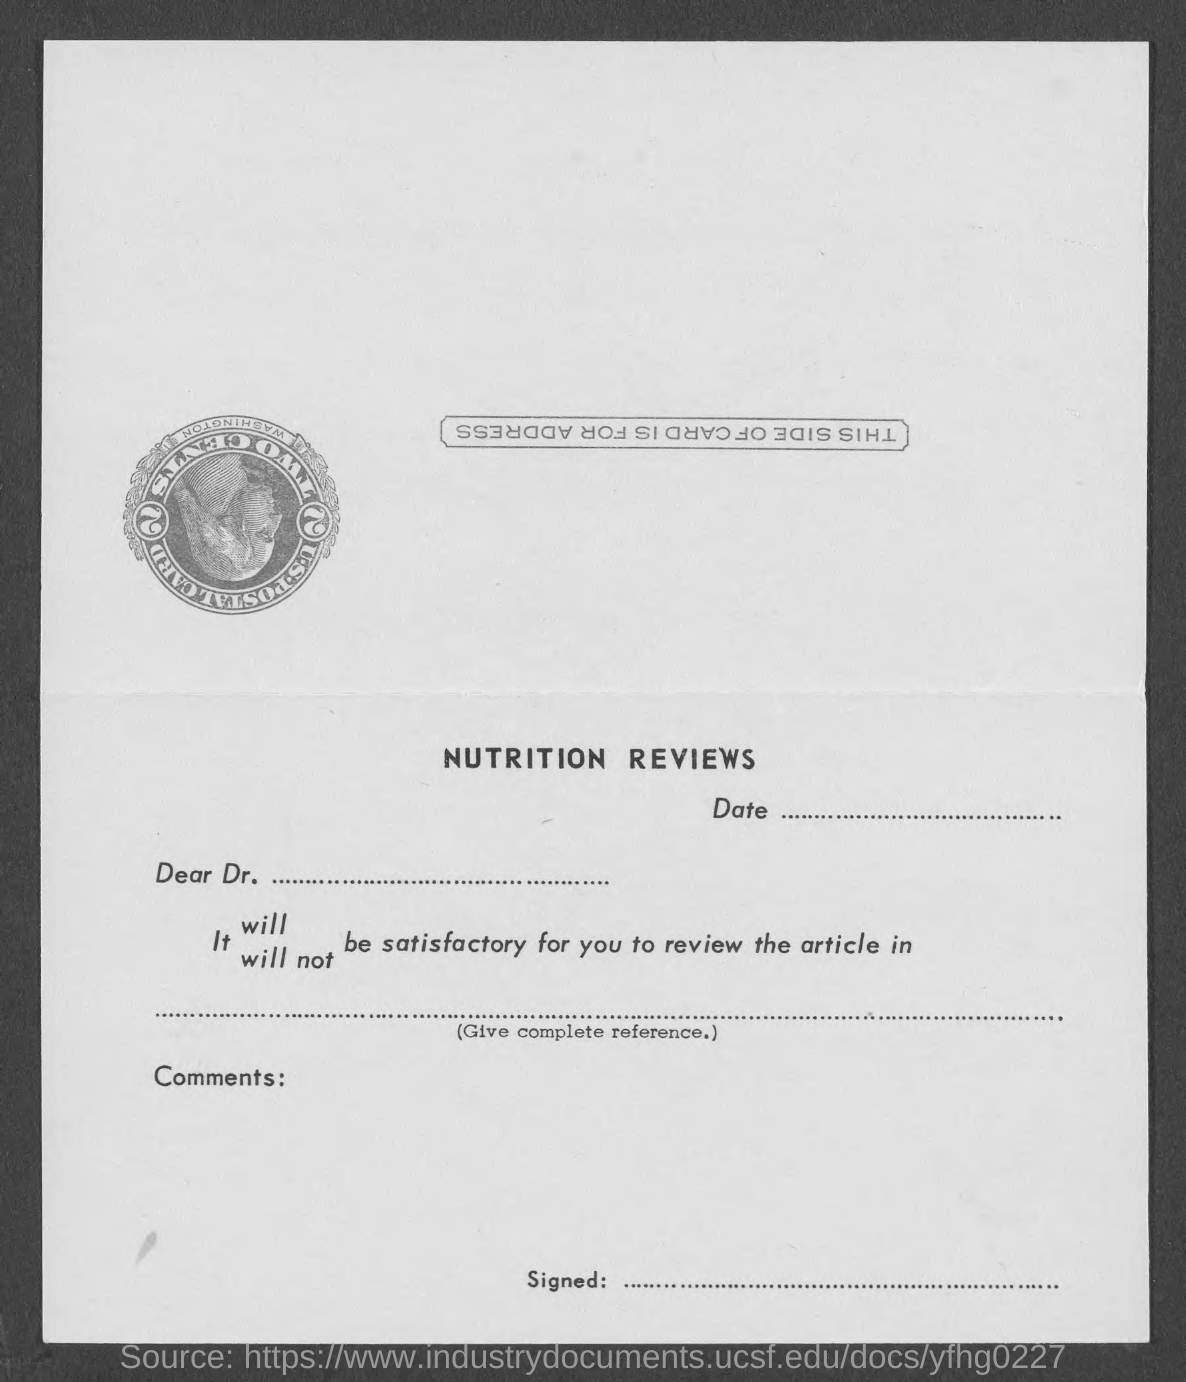What is this form on?
Ensure brevity in your answer.  Nutrition reviews. 